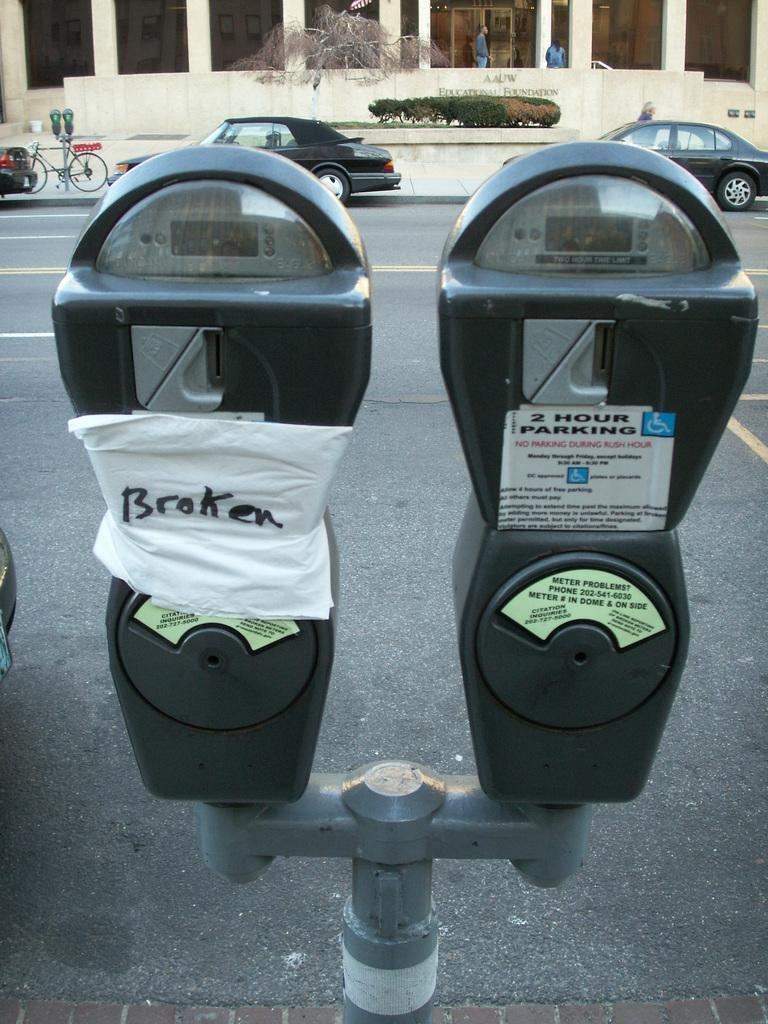What is the main feature of the image? There is a road in the image. What is happening on the road? There are vehicles on the road. Are there any people in the image? Yes, there are people visible in the image. What type of transportation can be seen in the image besides vehicles? There is a cycle in the image. What object related to parking is present in the image? There is a parking meter in the image. What type of marble is being used to decorate the mother's house in the image? There is no mention of marble or a mother's house in the image; the image features a road, vehicles, people, a cycle, and a parking meter. 